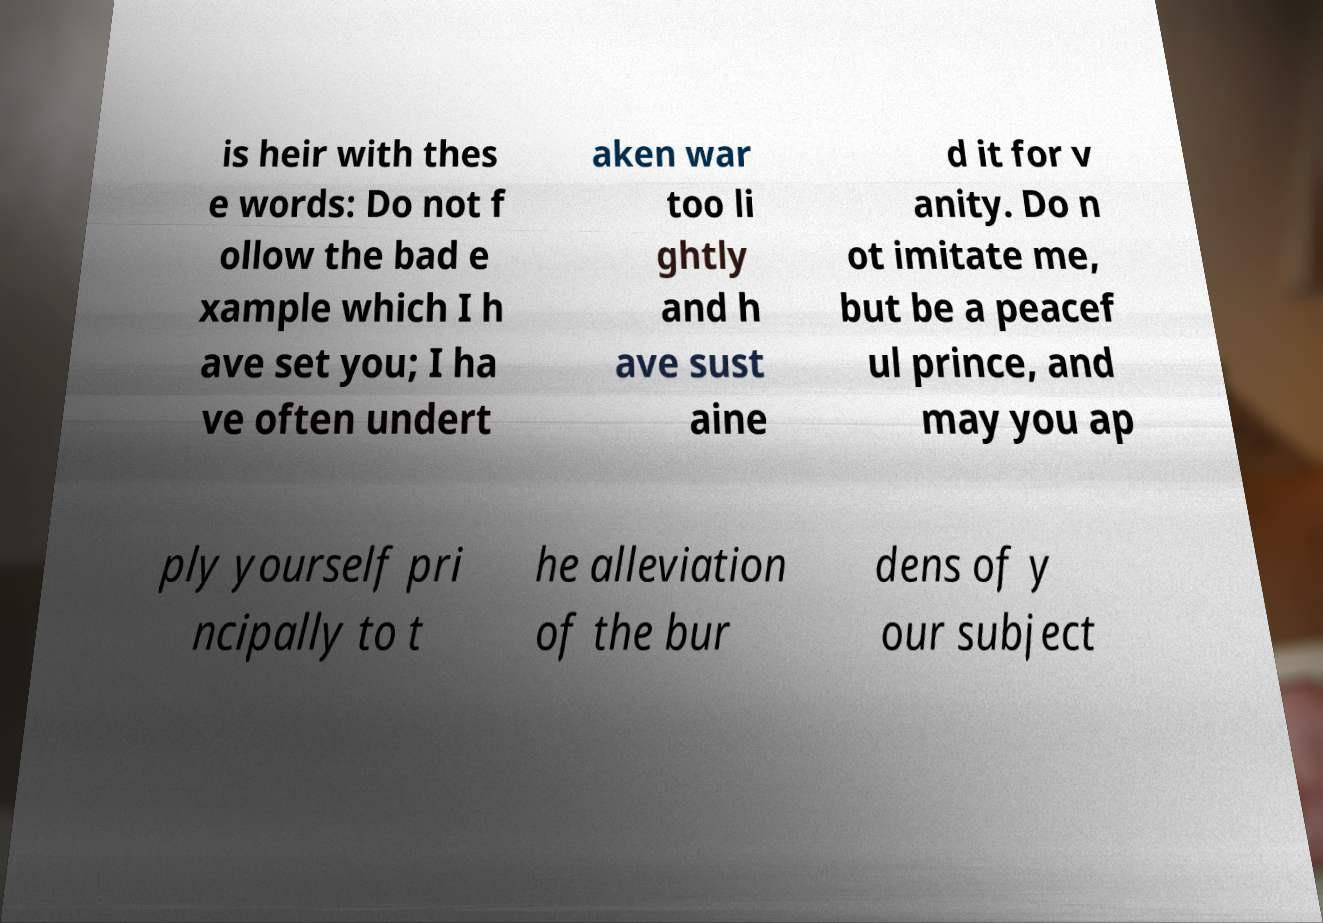There's text embedded in this image that I need extracted. Can you transcribe it verbatim? is heir with thes e words: Do not f ollow the bad e xample which I h ave set you; I ha ve often undert aken war too li ghtly and h ave sust aine d it for v anity. Do n ot imitate me, but be a peacef ul prince, and may you ap ply yourself pri ncipally to t he alleviation of the bur dens of y our subject 